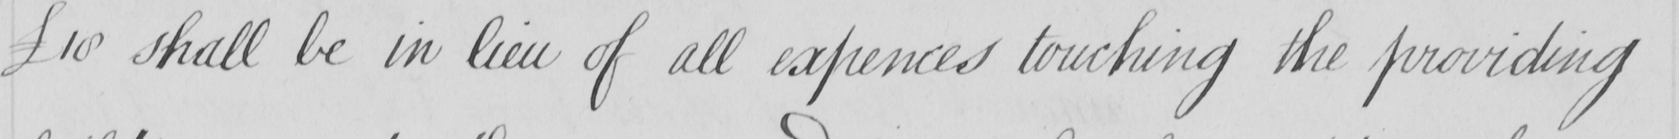What does this handwritten line say? £10 shall be in lieu of all expences touching the providing 